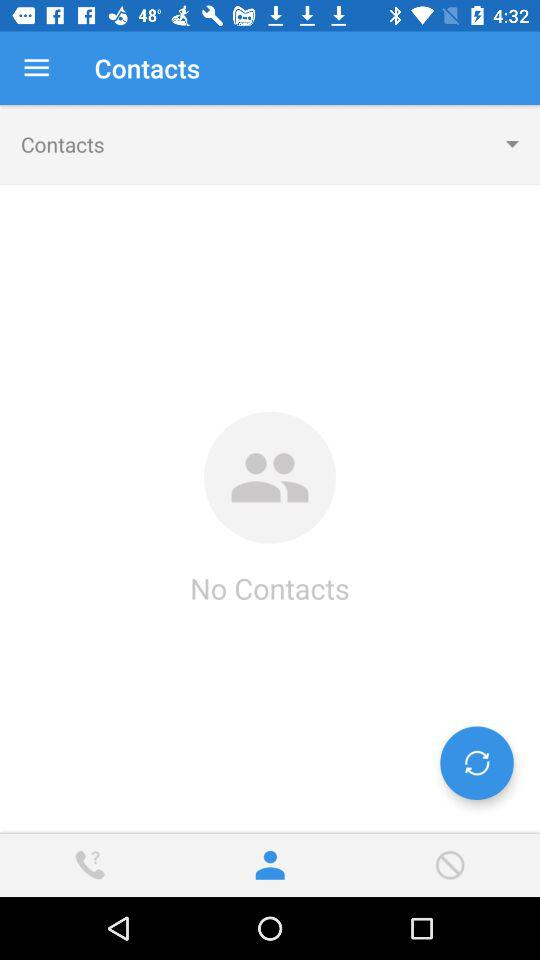How many contacts are there? There are no contacts. 